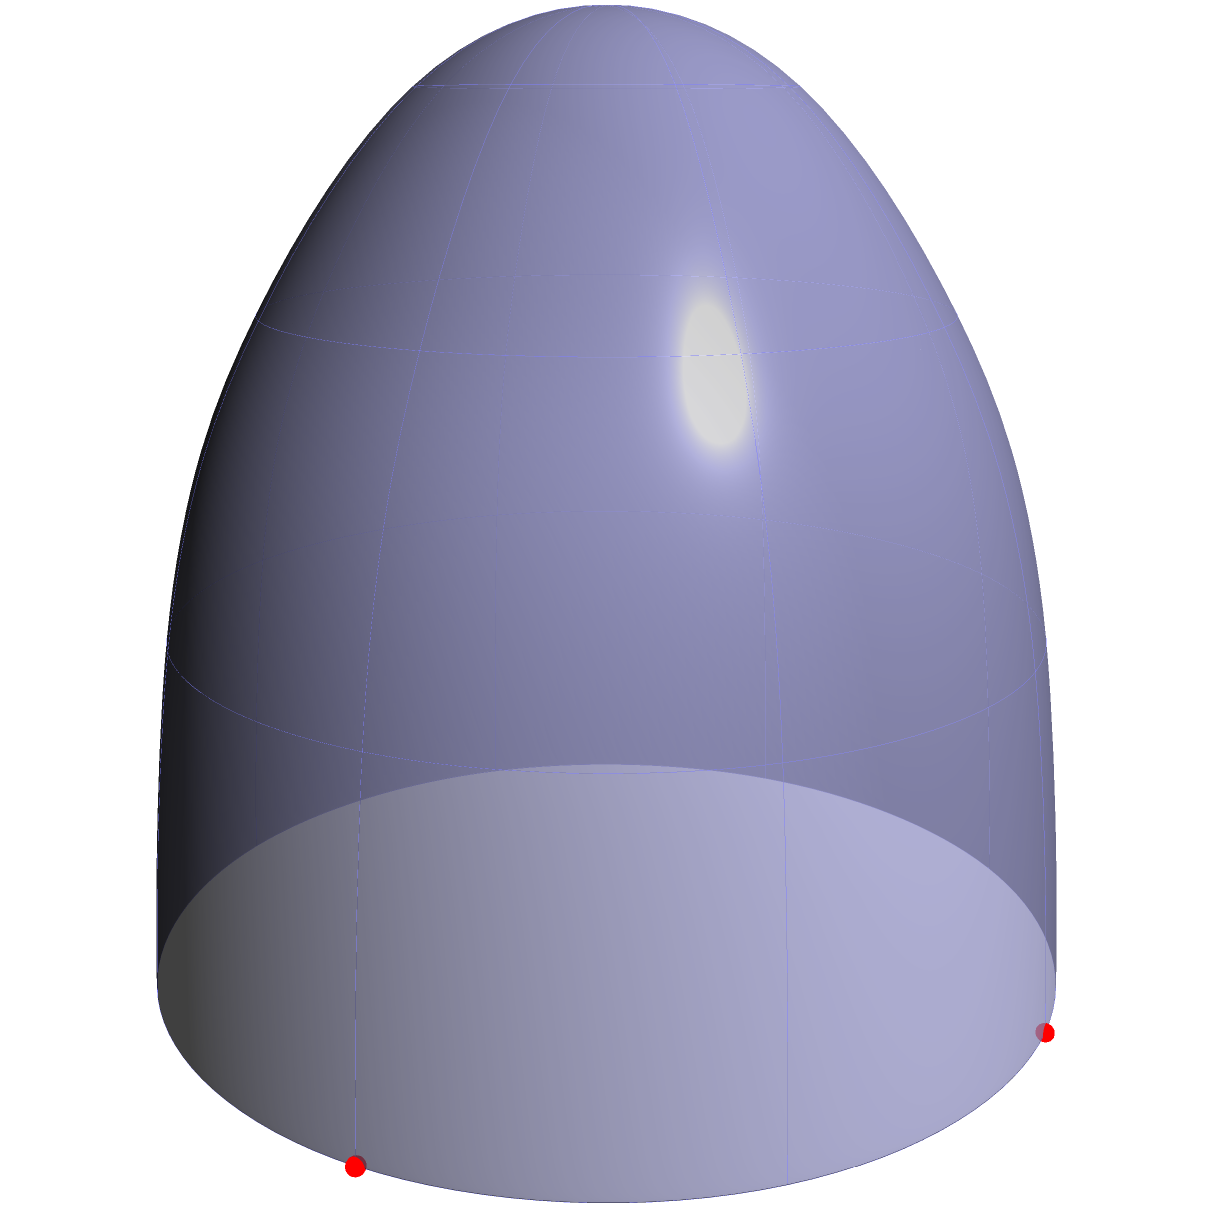In the context of monitoring charity fund distribution across different regions, consider a spherical model of the Earth with radius $R$. If two charity distribution centers are located at points A (0°, 0°) and B (90°, 0°) in terms of longitude and latitude, what is the shortest path distance between these two points along the surface of the sphere? To find the shortest path (geodesic) between two points on a sphere, we need to calculate the great circle distance. Here's how we can approach this problem:

1) The points A and B are located on the equator, 90° apart. This forms a quarter of a great circle.

2) The formula for the arc length $s$ on a sphere is:
   $s = R\theta$
   where $R$ is the radius of the sphere and $\theta$ is the central angle in radians.

3) We need to convert the 90° angle to radians:
   $\theta = 90° \times \frac{\pi}{180°} = \frac{\pi}{2}$ radians

4) Now we can substitute into our arc length formula:
   $s = R \times \frac{\pi}{2}$

5) This gives us the shortest path distance between A and B along the surface of the sphere.

In the context of charity fund distribution, this calculation could represent the most efficient route for transporting resources between two distribution centers, helping to optimize logistics and reduce transportation costs.
Answer: $\frac{\pi R}{2}$ 